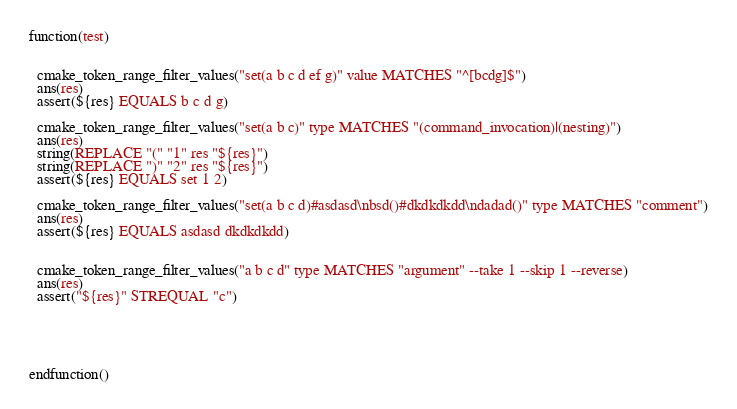<code> <loc_0><loc_0><loc_500><loc_500><_CMake_>function(test)


  cmake_token_range_filter_values("set(a b c d ef g)" value MATCHES "^[bcdg]$")
  ans(res)
  assert(${res} EQUALS b c d g)

  cmake_token_range_filter_values("set(a b c)" type MATCHES "(command_invocation)|(nesting)")
  ans(res)
  string(REPLACE "(" "1" res "${res}")
  string(REPLACE ")" "2" res "${res}")
  assert(${res} EQUALS set 1 2)

  cmake_token_range_filter_values("set(a b c d)#asdasd\nbsd()#dkdkdkdd\ndadad()" type MATCHES "comment")
  ans(res)
  assert(${res} EQUALS asdasd dkdkdkdd) 
  

  cmake_token_range_filter_values("a b c d" type MATCHES "argument" --take 1 --skip 1 --reverse)
  ans(res)
  assert("${res}" STREQUAL "c")



  

endfunction()</code> 